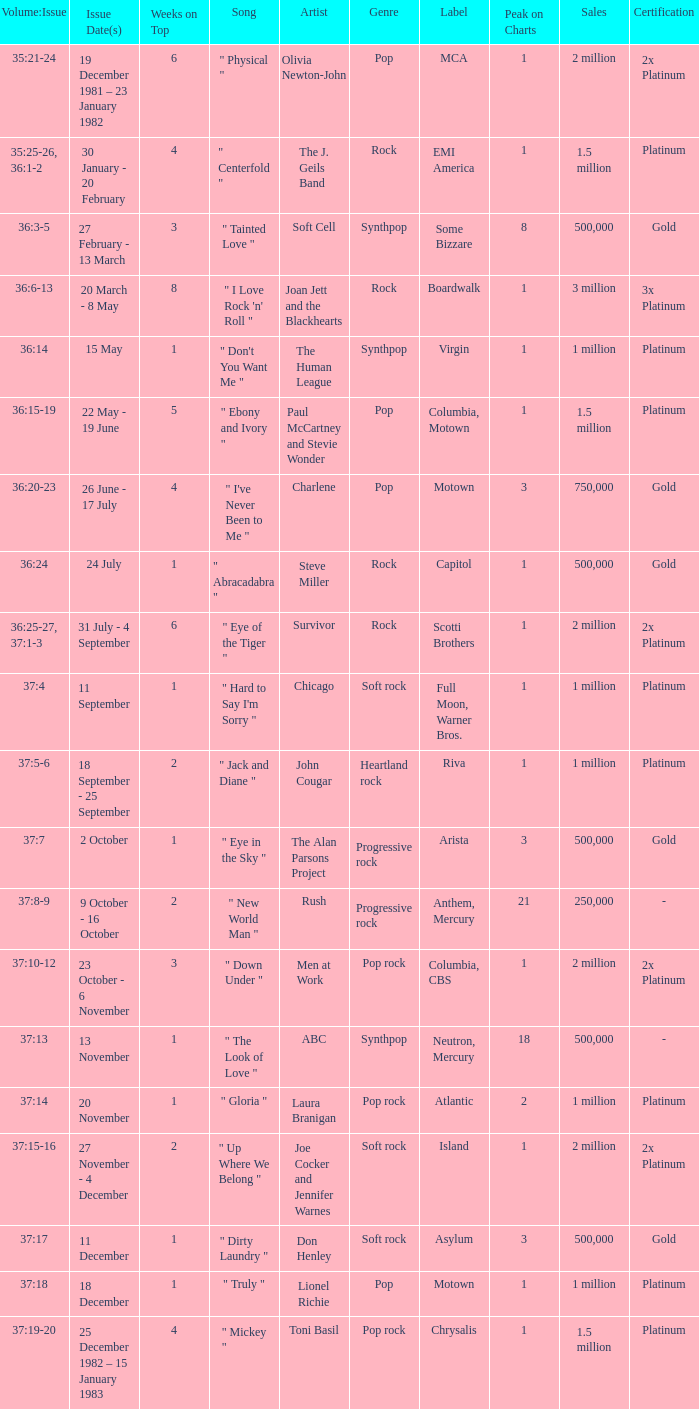Which Issue Date(s) has an Artist of men at work? 23 October - 6 November. 